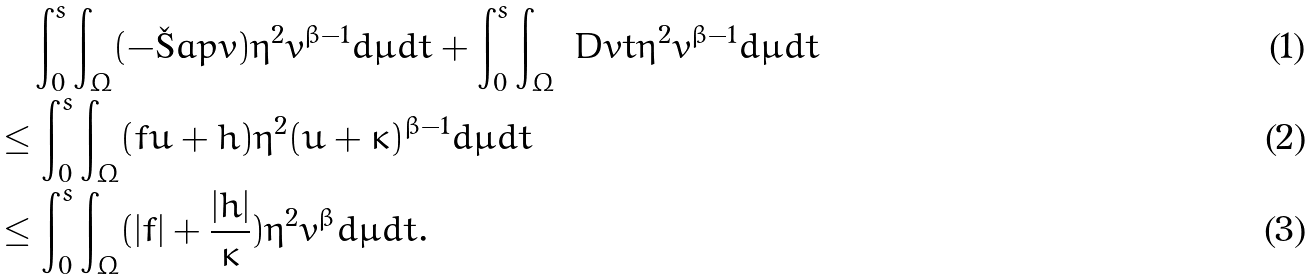Convert formula to latex. <formula><loc_0><loc_0><loc_500><loc_500>& \quad \int _ { 0 } ^ { s } \int _ { \Omega } ( - \L a p v ) \eta ^ { 2 } v ^ { \beta - 1 } d \mu d t + \int _ { 0 } ^ { s } \int _ { \Omega } \ D { v } { t } \eta ^ { 2 } v ^ { \beta - 1 } d \mu d t \\ & \leq \int _ { 0 } ^ { s } \int _ { \Omega } ( f u + h ) \eta ^ { 2 } ( u + \kappa ) ^ { \beta - 1 } d \mu d t \\ & \leq \int _ { 0 } ^ { s } \int _ { \Omega } ( | f | + \frac { | h | } { \kappa } ) \eta ^ { 2 } v ^ { \beta } d \mu d t .</formula> 